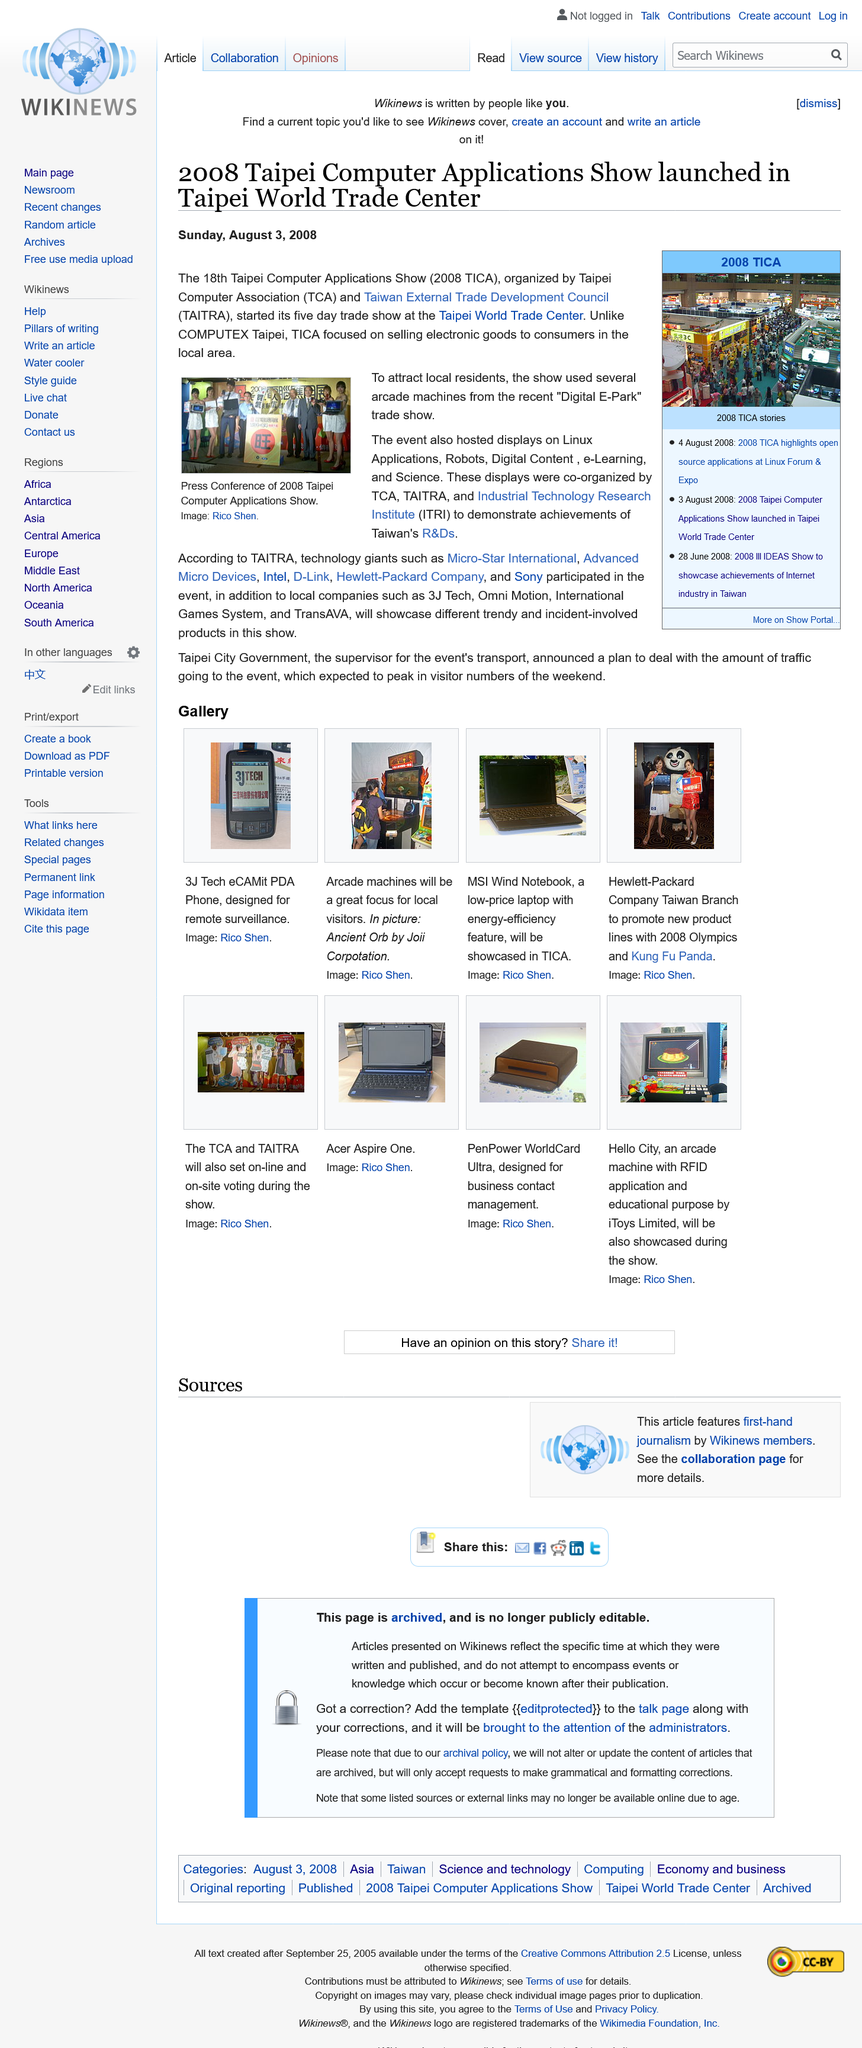Draw attention to some important aspects in this diagram. The 18th Taipei Computer Show took place at the Taipei World Trade Center. The TCA stands for Taipei Computer Association, a well-known organization in the technology industry that promotes the growth and development of the computer and related industries in Taiwan. The photo was taken by Rico Shen. 